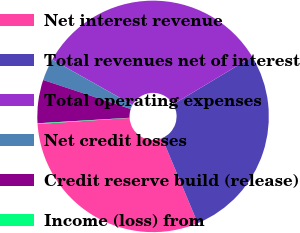Convert chart. <chart><loc_0><loc_0><loc_500><loc_500><pie_chart><fcel>Net interest revenue<fcel>Total revenues net of interest<fcel>Total operating expenses<fcel>Net credit losses<fcel>Credit reserve build (release)<fcel>Income (loss) from<nl><fcel>30.26%<fcel>27.3%<fcel>33.23%<fcel>3.07%<fcel>6.04%<fcel>0.1%<nl></chart> 